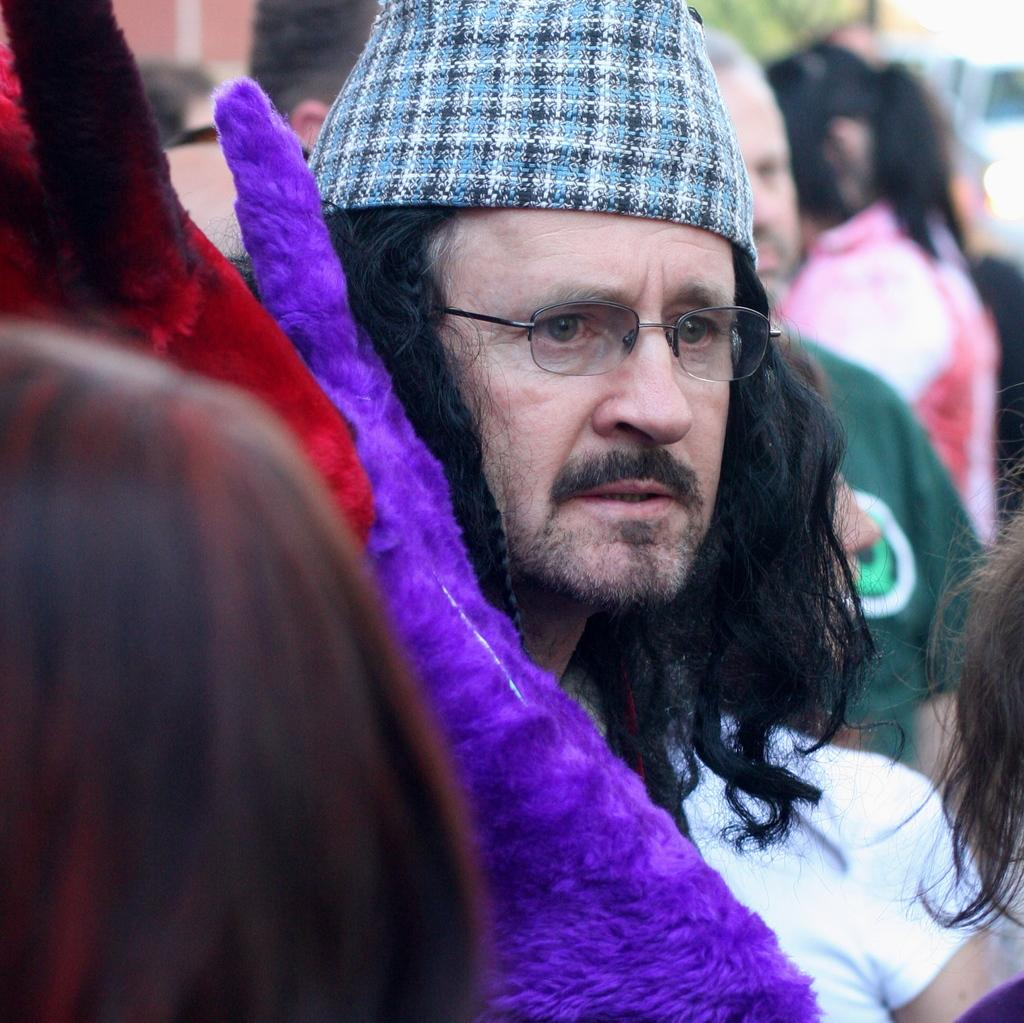What is happening in the image? There are people standing in the image. Can you describe the clothing of the people in the image? The people are wearing different color dresses. What can be observed about the background of the image? The background of the image is blurred. What type of note is being exchanged between the people in the image? There is no note being exchanged between the people in the image; they are simply standing. What kind of oatmeal is being served in the image? There is no oatmeal present in the image. 